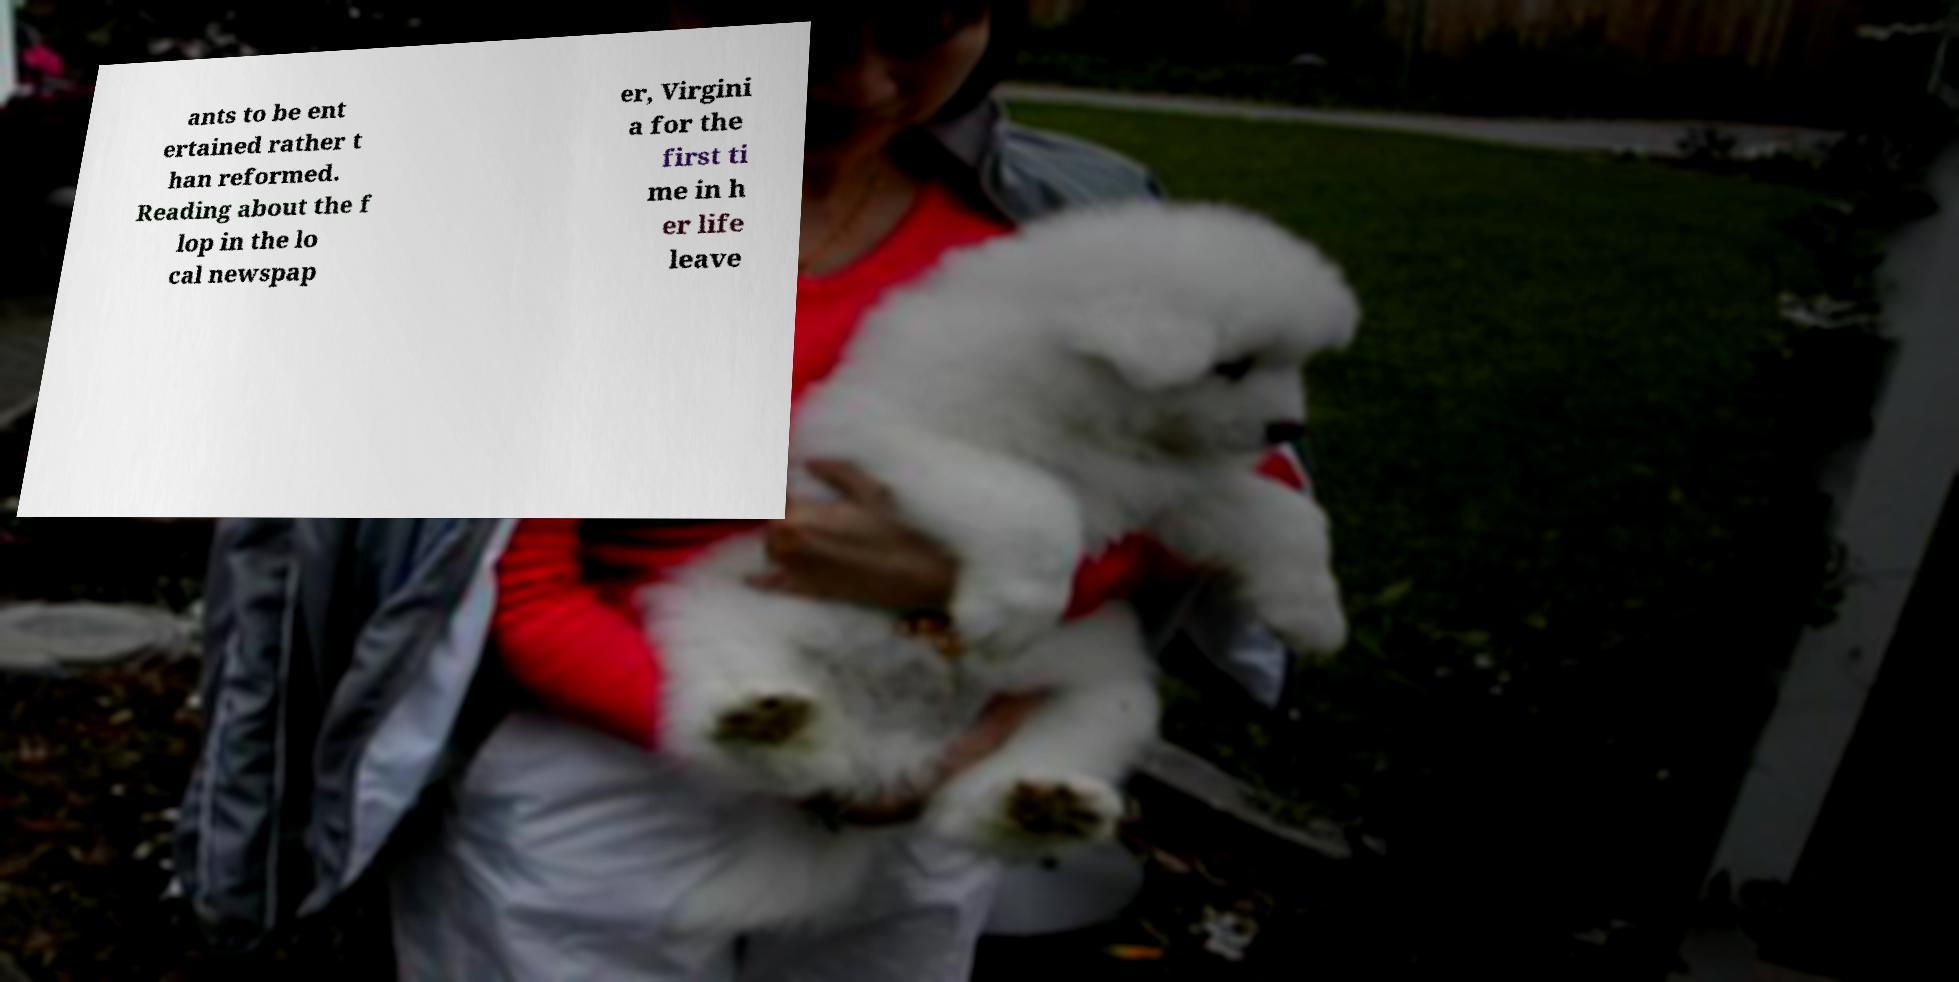Please identify and transcribe the text found in this image. ants to be ent ertained rather t han reformed. Reading about the f lop in the lo cal newspap er, Virgini a for the first ti me in h er life leave 